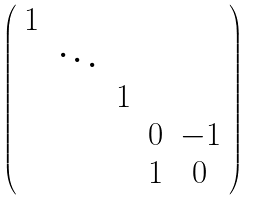<formula> <loc_0><loc_0><loc_500><loc_500>\left ( \begin{array} { c c c c c } 1 & & & & \\ & \ddots & & & \\ & & 1 & & \\ & & & 0 & - 1 \\ & & & 1 & 0 \\ \end{array} \right )</formula> 